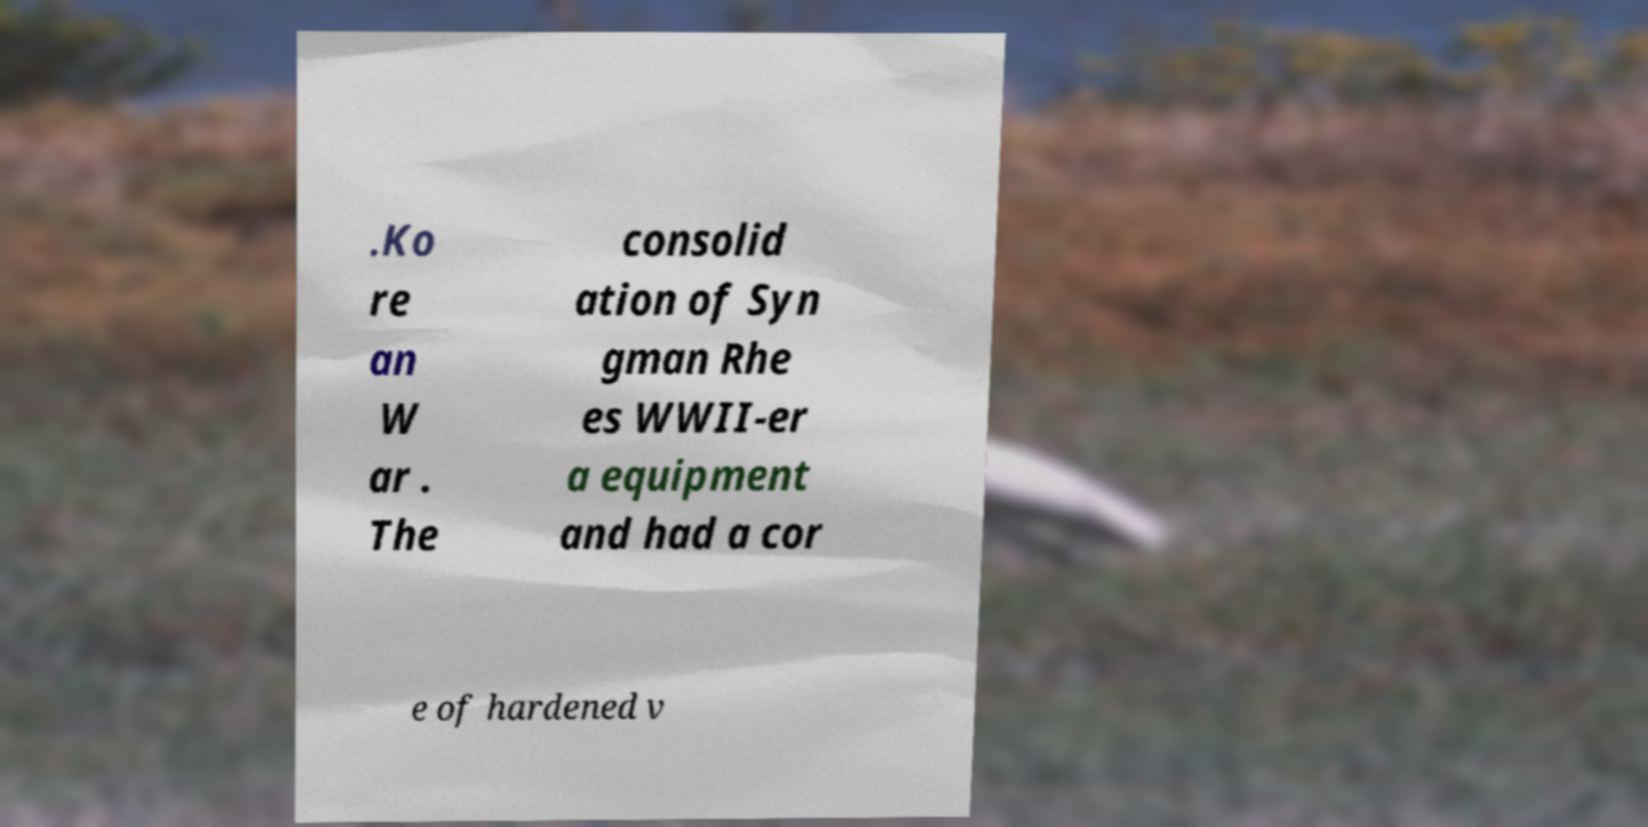There's text embedded in this image that I need extracted. Can you transcribe it verbatim? .Ko re an W ar . The consolid ation of Syn gman Rhe es WWII-er a equipment and had a cor e of hardened v 